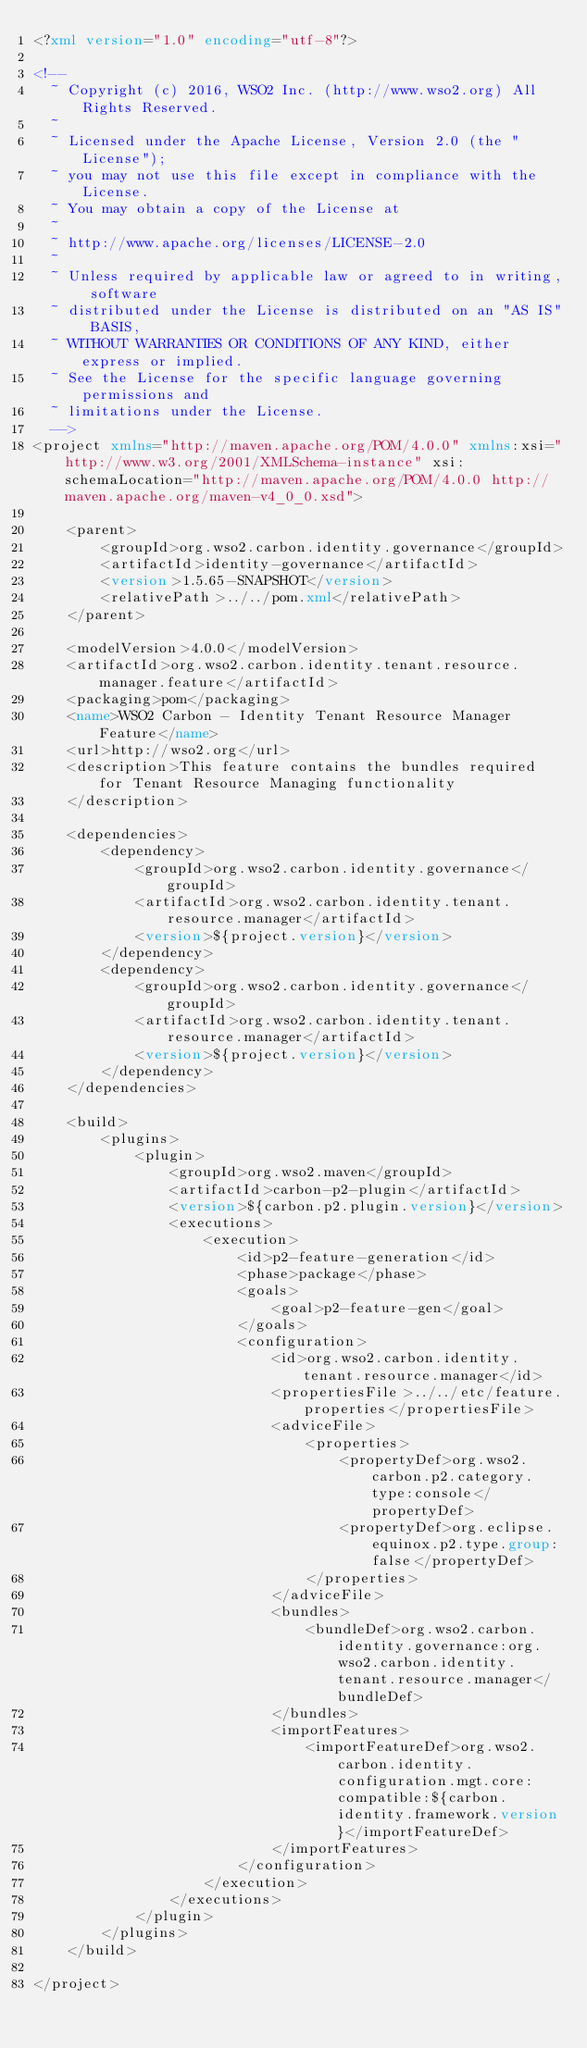<code> <loc_0><loc_0><loc_500><loc_500><_XML_><?xml version="1.0" encoding="utf-8"?>

<!--
  ~ Copyright (c) 2016, WSO2 Inc. (http://www.wso2.org) All Rights Reserved.
  ~
  ~ Licensed under the Apache License, Version 2.0 (the "License");
  ~ you may not use this file except in compliance with the License.
  ~ You may obtain a copy of the License at
  ~
  ~ http://www.apache.org/licenses/LICENSE-2.0
  ~
  ~ Unless required by applicable law or agreed to in writing, software
  ~ distributed under the License is distributed on an "AS IS" BASIS,
  ~ WITHOUT WARRANTIES OR CONDITIONS OF ANY KIND, either express or implied.
  ~ See the License for the specific language governing permissions and
  ~ limitations under the License.
  -->
<project xmlns="http://maven.apache.org/POM/4.0.0" xmlns:xsi="http://www.w3.org/2001/XMLSchema-instance" xsi:schemaLocation="http://maven.apache.org/POM/4.0.0 http://maven.apache.org/maven-v4_0_0.xsd">

    <parent>
        <groupId>org.wso2.carbon.identity.governance</groupId>
        <artifactId>identity-governance</artifactId>
        <version>1.5.65-SNAPSHOT</version>
        <relativePath>../../pom.xml</relativePath>
    </parent>

    <modelVersion>4.0.0</modelVersion>
    <artifactId>org.wso2.carbon.identity.tenant.resource.manager.feature</artifactId>
    <packaging>pom</packaging>
    <name>WSO2 Carbon - Identity Tenant Resource Manager Feature</name>
    <url>http://wso2.org</url>
    <description>This feature contains the bundles required for Tenant Resource Managing functionality
    </description>

    <dependencies>
        <dependency>
            <groupId>org.wso2.carbon.identity.governance</groupId>
            <artifactId>org.wso2.carbon.identity.tenant.resource.manager</artifactId>
            <version>${project.version}</version>
        </dependency>
        <dependency>
            <groupId>org.wso2.carbon.identity.governance</groupId>
            <artifactId>org.wso2.carbon.identity.tenant.resource.manager</artifactId>
            <version>${project.version}</version>
        </dependency>
    </dependencies>

    <build>
        <plugins>
            <plugin>
                <groupId>org.wso2.maven</groupId>
                <artifactId>carbon-p2-plugin</artifactId>
                <version>${carbon.p2.plugin.version}</version>
                <executions>
                    <execution>
                        <id>p2-feature-generation</id>
                        <phase>package</phase>
                        <goals>
                            <goal>p2-feature-gen</goal>
                        </goals>
                        <configuration>
                            <id>org.wso2.carbon.identity.tenant.resource.manager</id>
                            <propertiesFile>../../etc/feature.properties</propertiesFile>
                            <adviceFile>
                                <properties>
                                    <propertyDef>org.wso2.carbon.p2.category.type:console</propertyDef>
                                    <propertyDef>org.eclipse.equinox.p2.type.group:false</propertyDef>
                                </properties>
                            </adviceFile>
                            <bundles>
                                <bundleDef>org.wso2.carbon.identity.governance:org.wso2.carbon.identity.tenant.resource.manager</bundleDef>
                            </bundles>
                            <importFeatures>
                                <importFeatureDef>org.wso2.carbon.identity.configuration.mgt.core:compatible:${carbon.identity.framework.version}</importFeatureDef>
                            </importFeatures>
                        </configuration>
                    </execution>
                </executions>
            </plugin>
        </plugins>
    </build>

</project>
</code> 